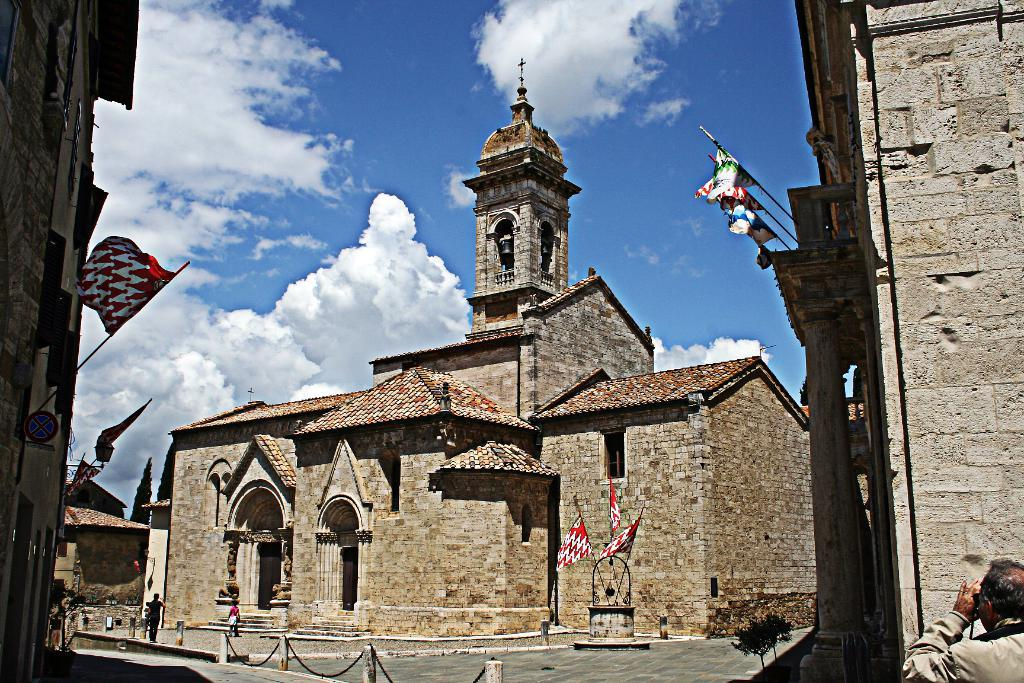What type of structure is in the image? There is a castle in the image. What is in front of the castle? The castle has flags in front of it. Are there any people in the image? Yes, there are people walking in the image. What can be seen in the sky in the image? The sky is visible in the image, and clouds are present in it. What type of toy can be seen playing with the people in the image? There is no toy present in the image; it features a castle with flags and people walking. Are there any fairies visible in the image? There are no fairies present in the image. 